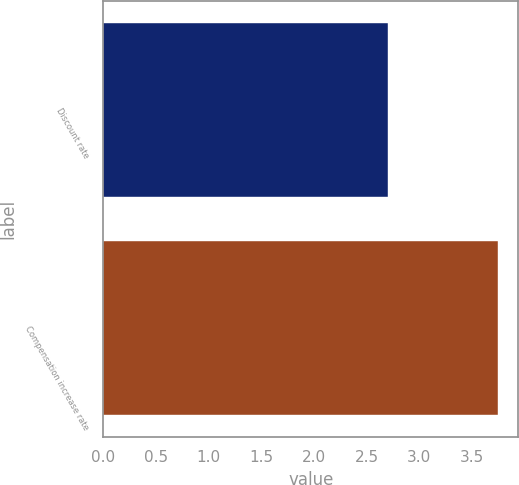Convert chart. <chart><loc_0><loc_0><loc_500><loc_500><bar_chart><fcel>Discount rate<fcel>Compensation increase rate<nl><fcel>2.7<fcel>3.75<nl></chart> 